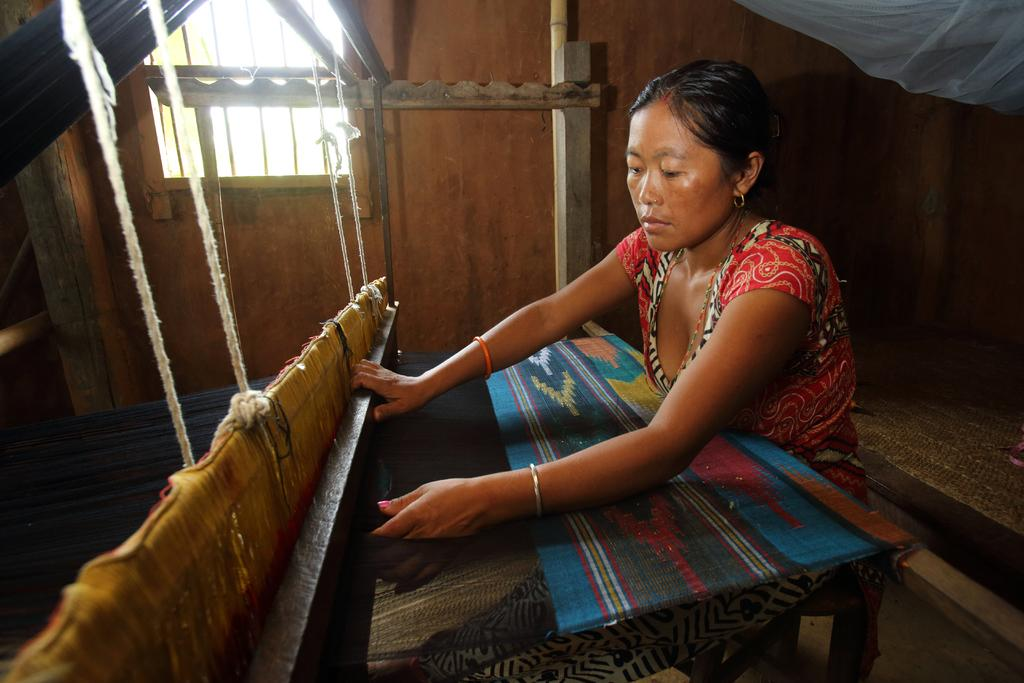Who is the main subject in the image? There is a woman in the image. What is the woman doing in the image? The woman is weaving a saree. What can be seen behind the woman? There is a wall behind the woman. Can you describe the window in the image? There is a window on the left side of the wall. What type of soup is the woman eating while weaving the saree in the image? There is no soup present in the image; the woman is weaving a saree. Can you hear the woman singing while she weaves the saree in the image? The image is a still image, so it does not convey sound. Therefore, we cannot determine if the woman is singing or not. 